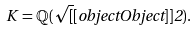Convert formula to latex. <formula><loc_0><loc_0><loc_500><loc_500>K = \mathbb { Q } ( { \sqrt { [ } [ o b j e c t O b j e c t ] ] { 2 } } ) .</formula> 